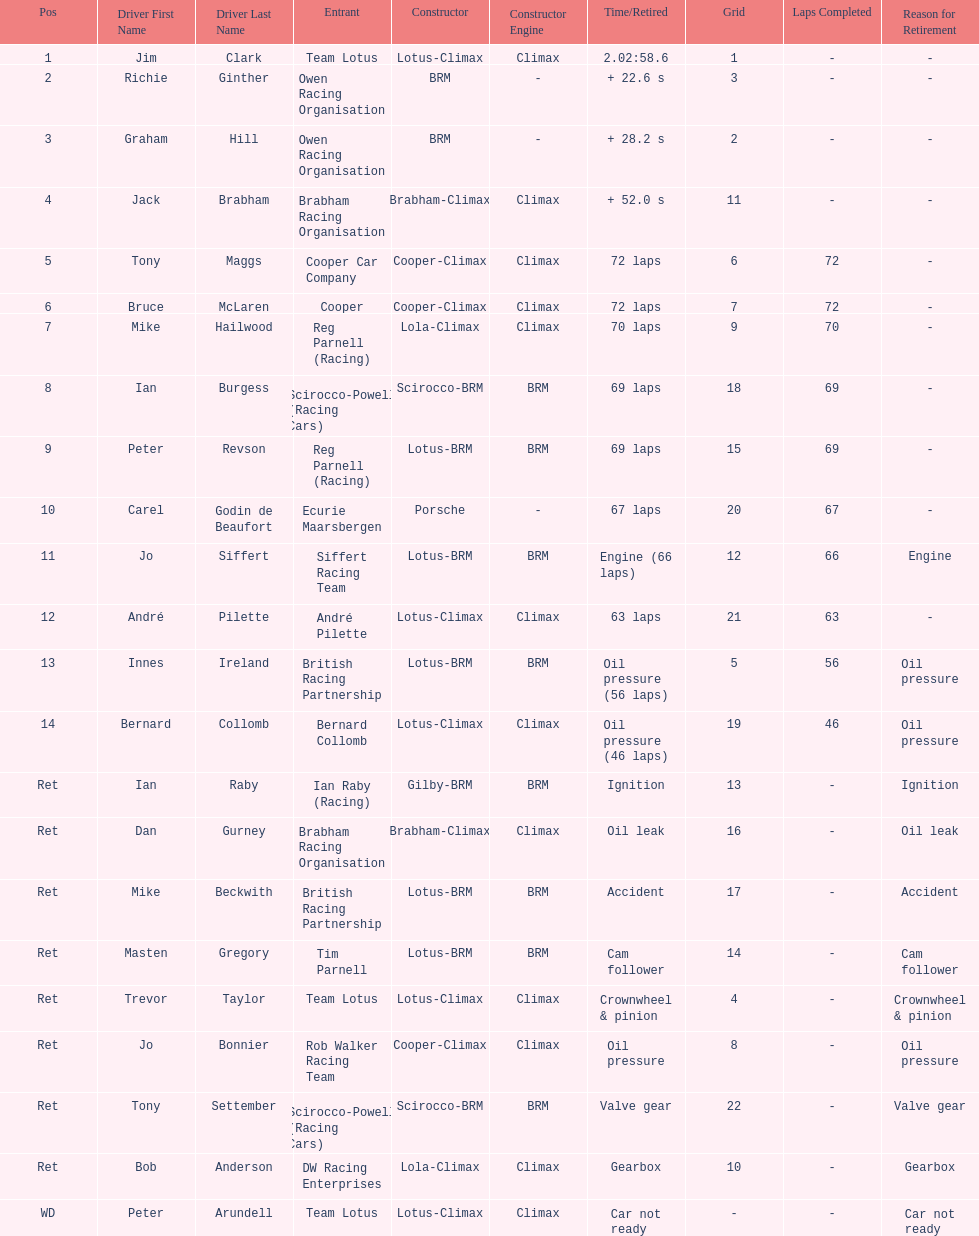How many racers had cooper-climax as their constructor? 3. 